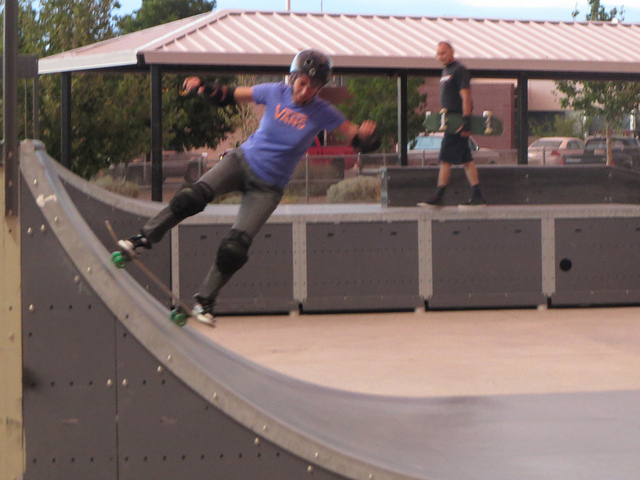Please provide a short description for this region: [0.18, 0.2, 0.6, 0.63]. A skateboarder is captured mid-action on a ramp, sporting a blue Vans t-shirt and protective gear. 